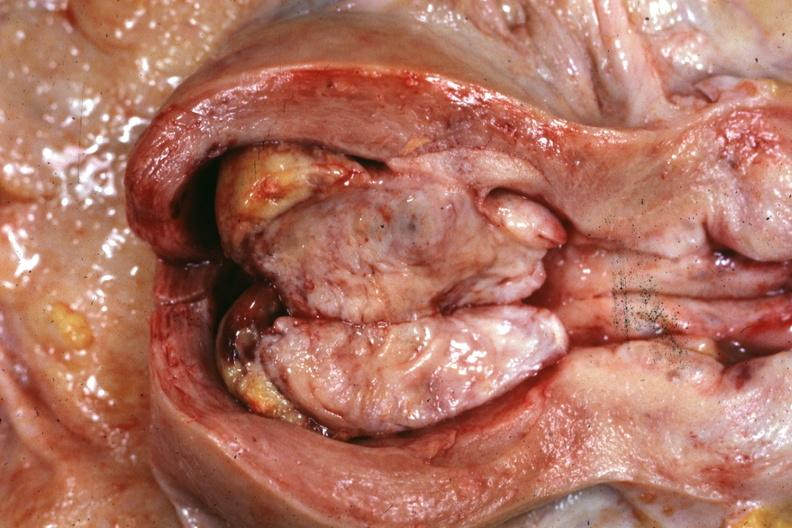s glioma present?
Answer the question using a single word or phrase. No 